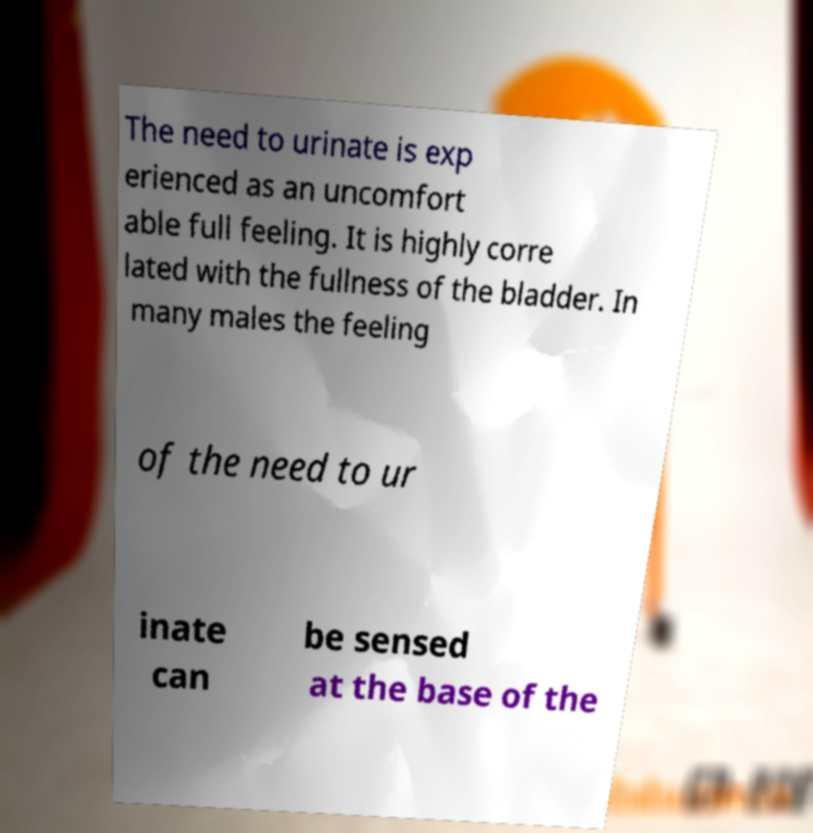Please identify and transcribe the text found in this image. The need to urinate is exp erienced as an uncomfort able full feeling. It is highly corre lated with the fullness of the bladder. In many males the feeling of the need to ur inate can be sensed at the base of the 